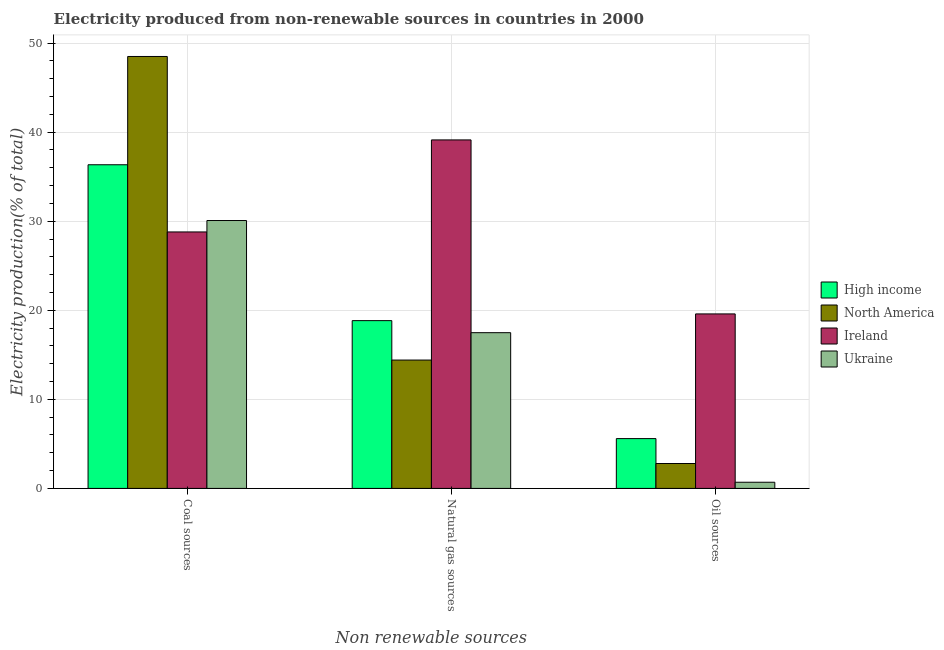How many bars are there on the 2nd tick from the left?
Give a very brief answer. 4. What is the label of the 1st group of bars from the left?
Make the answer very short. Coal sources. What is the percentage of electricity produced by coal in Ireland?
Your answer should be very brief. 28.8. Across all countries, what is the maximum percentage of electricity produced by oil sources?
Ensure brevity in your answer.  19.59. Across all countries, what is the minimum percentage of electricity produced by natural gas?
Your answer should be very brief. 14.41. In which country was the percentage of electricity produced by coal minimum?
Keep it short and to the point. Ireland. What is the total percentage of electricity produced by natural gas in the graph?
Give a very brief answer. 89.86. What is the difference between the percentage of electricity produced by natural gas in Ukraine and that in High income?
Ensure brevity in your answer.  -1.35. What is the difference between the percentage of electricity produced by oil sources in High income and the percentage of electricity produced by coal in North America?
Your answer should be compact. -42.9. What is the average percentage of electricity produced by coal per country?
Offer a terse response. 35.93. What is the difference between the percentage of electricity produced by coal and percentage of electricity produced by oil sources in Ireland?
Your answer should be very brief. 9.2. In how many countries, is the percentage of electricity produced by natural gas greater than 12 %?
Your response must be concise. 4. What is the ratio of the percentage of electricity produced by oil sources in North America to that in High income?
Make the answer very short. 0.5. Is the difference between the percentage of electricity produced by natural gas in Ukraine and North America greater than the difference between the percentage of electricity produced by oil sources in Ukraine and North America?
Keep it short and to the point. Yes. What is the difference between the highest and the second highest percentage of electricity produced by coal?
Make the answer very short. 12.16. What is the difference between the highest and the lowest percentage of electricity produced by natural gas?
Provide a succinct answer. 24.72. In how many countries, is the percentage of electricity produced by oil sources greater than the average percentage of electricity produced by oil sources taken over all countries?
Your answer should be compact. 1. What does the 2nd bar from the right in Oil sources represents?
Make the answer very short. Ireland. Does the graph contain any zero values?
Your answer should be very brief. No. Does the graph contain grids?
Offer a terse response. Yes. How many legend labels are there?
Your answer should be compact. 4. What is the title of the graph?
Provide a succinct answer. Electricity produced from non-renewable sources in countries in 2000. Does "Ecuador" appear as one of the legend labels in the graph?
Provide a succinct answer. No. What is the label or title of the X-axis?
Your response must be concise. Non renewable sources. What is the label or title of the Y-axis?
Give a very brief answer. Electricity production(% of total). What is the Electricity production(% of total) of High income in Coal sources?
Your answer should be very brief. 36.34. What is the Electricity production(% of total) of North America in Coal sources?
Your response must be concise. 48.5. What is the Electricity production(% of total) in Ireland in Coal sources?
Your response must be concise. 28.8. What is the Electricity production(% of total) of Ukraine in Coal sources?
Provide a short and direct response. 30.08. What is the Electricity production(% of total) of High income in Natural gas sources?
Ensure brevity in your answer.  18.84. What is the Electricity production(% of total) in North America in Natural gas sources?
Ensure brevity in your answer.  14.41. What is the Electricity production(% of total) of Ireland in Natural gas sources?
Your answer should be very brief. 39.13. What is the Electricity production(% of total) in Ukraine in Natural gas sources?
Offer a terse response. 17.49. What is the Electricity production(% of total) of High income in Oil sources?
Offer a very short reply. 5.59. What is the Electricity production(% of total) of North America in Oil sources?
Provide a succinct answer. 2.8. What is the Electricity production(% of total) of Ireland in Oil sources?
Ensure brevity in your answer.  19.59. What is the Electricity production(% of total) of Ukraine in Oil sources?
Offer a terse response. 0.69. Across all Non renewable sources, what is the maximum Electricity production(% of total) of High income?
Provide a short and direct response. 36.34. Across all Non renewable sources, what is the maximum Electricity production(% of total) of North America?
Your response must be concise. 48.5. Across all Non renewable sources, what is the maximum Electricity production(% of total) in Ireland?
Offer a terse response. 39.13. Across all Non renewable sources, what is the maximum Electricity production(% of total) in Ukraine?
Your answer should be compact. 30.08. Across all Non renewable sources, what is the minimum Electricity production(% of total) of High income?
Offer a very short reply. 5.59. Across all Non renewable sources, what is the minimum Electricity production(% of total) of North America?
Offer a terse response. 2.8. Across all Non renewable sources, what is the minimum Electricity production(% of total) in Ireland?
Your answer should be very brief. 19.59. Across all Non renewable sources, what is the minimum Electricity production(% of total) of Ukraine?
Your answer should be very brief. 0.69. What is the total Electricity production(% of total) of High income in the graph?
Offer a very short reply. 60.77. What is the total Electricity production(% of total) of North America in the graph?
Keep it short and to the point. 65.71. What is the total Electricity production(% of total) of Ireland in the graph?
Make the answer very short. 87.52. What is the total Electricity production(% of total) of Ukraine in the graph?
Make the answer very short. 48.26. What is the difference between the Electricity production(% of total) of High income in Coal sources and that in Natural gas sources?
Your response must be concise. 17.5. What is the difference between the Electricity production(% of total) in North America in Coal sources and that in Natural gas sources?
Your response must be concise. 34.09. What is the difference between the Electricity production(% of total) of Ireland in Coal sources and that in Natural gas sources?
Your answer should be compact. -10.33. What is the difference between the Electricity production(% of total) of Ukraine in Coal sources and that in Natural gas sources?
Your answer should be compact. 12.59. What is the difference between the Electricity production(% of total) in High income in Coal sources and that in Oil sources?
Your answer should be very brief. 30.75. What is the difference between the Electricity production(% of total) in North America in Coal sources and that in Oil sources?
Offer a very short reply. 45.7. What is the difference between the Electricity production(% of total) of Ireland in Coal sources and that in Oil sources?
Your answer should be compact. 9.2. What is the difference between the Electricity production(% of total) in Ukraine in Coal sources and that in Oil sources?
Offer a terse response. 29.38. What is the difference between the Electricity production(% of total) of High income in Natural gas sources and that in Oil sources?
Give a very brief answer. 13.25. What is the difference between the Electricity production(% of total) of North America in Natural gas sources and that in Oil sources?
Provide a short and direct response. 11.62. What is the difference between the Electricity production(% of total) of Ireland in Natural gas sources and that in Oil sources?
Your response must be concise. 19.54. What is the difference between the Electricity production(% of total) in Ukraine in Natural gas sources and that in Oil sources?
Give a very brief answer. 16.79. What is the difference between the Electricity production(% of total) of High income in Coal sources and the Electricity production(% of total) of North America in Natural gas sources?
Provide a short and direct response. 21.93. What is the difference between the Electricity production(% of total) in High income in Coal sources and the Electricity production(% of total) in Ireland in Natural gas sources?
Make the answer very short. -2.79. What is the difference between the Electricity production(% of total) of High income in Coal sources and the Electricity production(% of total) of Ukraine in Natural gas sources?
Keep it short and to the point. 18.85. What is the difference between the Electricity production(% of total) of North America in Coal sources and the Electricity production(% of total) of Ireland in Natural gas sources?
Ensure brevity in your answer.  9.37. What is the difference between the Electricity production(% of total) of North America in Coal sources and the Electricity production(% of total) of Ukraine in Natural gas sources?
Provide a succinct answer. 31.01. What is the difference between the Electricity production(% of total) in Ireland in Coal sources and the Electricity production(% of total) in Ukraine in Natural gas sources?
Your answer should be compact. 11.31. What is the difference between the Electricity production(% of total) of High income in Coal sources and the Electricity production(% of total) of North America in Oil sources?
Your answer should be compact. 33.54. What is the difference between the Electricity production(% of total) in High income in Coal sources and the Electricity production(% of total) in Ireland in Oil sources?
Provide a short and direct response. 16.75. What is the difference between the Electricity production(% of total) in High income in Coal sources and the Electricity production(% of total) in Ukraine in Oil sources?
Your answer should be compact. 35.65. What is the difference between the Electricity production(% of total) of North America in Coal sources and the Electricity production(% of total) of Ireland in Oil sources?
Make the answer very short. 28.91. What is the difference between the Electricity production(% of total) in North America in Coal sources and the Electricity production(% of total) in Ukraine in Oil sources?
Ensure brevity in your answer.  47.8. What is the difference between the Electricity production(% of total) of Ireland in Coal sources and the Electricity production(% of total) of Ukraine in Oil sources?
Make the answer very short. 28.1. What is the difference between the Electricity production(% of total) in High income in Natural gas sources and the Electricity production(% of total) in North America in Oil sources?
Your response must be concise. 16.04. What is the difference between the Electricity production(% of total) of High income in Natural gas sources and the Electricity production(% of total) of Ireland in Oil sources?
Offer a terse response. -0.75. What is the difference between the Electricity production(% of total) of High income in Natural gas sources and the Electricity production(% of total) of Ukraine in Oil sources?
Give a very brief answer. 18.15. What is the difference between the Electricity production(% of total) in North America in Natural gas sources and the Electricity production(% of total) in Ireland in Oil sources?
Provide a short and direct response. -5.18. What is the difference between the Electricity production(% of total) in North America in Natural gas sources and the Electricity production(% of total) in Ukraine in Oil sources?
Your response must be concise. 13.72. What is the difference between the Electricity production(% of total) of Ireland in Natural gas sources and the Electricity production(% of total) of Ukraine in Oil sources?
Offer a very short reply. 38.44. What is the average Electricity production(% of total) in High income per Non renewable sources?
Offer a terse response. 20.26. What is the average Electricity production(% of total) of North America per Non renewable sources?
Ensure brevity in your answer.  21.9. What is the average Electricity production(% of total) of Ireland per Non renewable sources?
Provide a succinct answer. 29.17. What is the average Electricity production(% of total) of Ukraine per Non renewable sources?
Make the answer very short. 16.09. What is the difference between the Electricity production(% of total) in High income and Electricity production(% of total) in North America in Coal sources?
Provide a short and direct response. -12.16. What is the difference between the Electricity production(% of total) in High income and Electricity production(% of total) in Ireland in Coal sources?
Provide a succinct answer. 7.54. What is the difference between the Electricity production(% of total) of High income and Electricity production(% of total) of Ukraine in Coal sources?
Make the answer very short. 6.26. What is the difference between the Electricity production(% of total) of North America and Electricity production(% of total) of Ireland in Coal sources?
Provide a succinct answer. 19.7. What is the difference between the Electricity production(% of total) in North America and Electricity production(% of total) in Ukraine in Coal sources?
Provide a succinct answer. 18.42. What is the difference between the Electricity production(% of total) in Ireland and Electricity production(% of total) in Ukraine in Coal sources?
Ensure brevity in your answer.  -1.28. What is the difference between the Electricity production(% of total) of High income and Electricity production(% of total) of North America in Natural gas sources?
Keep it short and to the point. 4.43. What is the difference between the Electricity production(% of total) of High income and Electricity production(% of total) of Ireland in Natural gas sources?
Ensure brevity in your answer.  -20.29. What is the difference between the Electricity production(% of total) in High income and Electricity production(% of total) in Ukraine in Natural gas sources?
Provide a succinct answer. 1.35. What is the difference between the Electricity production(% of total) of North America and Electricity production(% of total) of Ireland in Natural gas sources?
Provide a short and direct response. -24.72. What is the difference between the Electricity production(% of total) in North America and Electricity production(% of total) in Ukraine in Natural gas sources?
Your response must be concise. -3.07. What is the difference between the Electricity production(% of total) of Ireland and Electricity production(% of total) of Ukraine in Natural gas sources?
Provide a short and direct response. 21.64. What is the difference between the Electricity production(% of total) in High income and Electricity production(% of total) in North America in Oil sources?
Provide a short and direct response. 2.8. What is the difference between the Electricity production(% of total) of High income and Electricity production(% of total) of Ireland in Oil sources?
Your answer should be compact. -14. What is the difference between the Electricity production(% of total) in High income and Electricity production(% of total) in Ukraine in Oil sources?
Your response must be concise. 4.9. What is the difference between the Electricity production(% of total) of North America and Electricity production(% of total) of Ireland in Oil sources?
Your response must be concise. -16.8. What is the difference between the Electricity production(% of total) in North America and Electricity production(% of total) in Ukraine in Oil sources?
Keep it short and to the point. 2.1. What is the difference between the Electricity production(% of total) in Ireland and Electricity production(% of total) in Ukraine in Oil sources?
Offer a terse response. 18.9. What is the ratio of the Electricity production(% of total) in High income in Coal sources to that in Natural gas sources?
Your answer should be compact. 1.93. What is the ratio of the Electricity production(% of total) in North America in Coal sources to that in Natural gas sources?
Ensure brevity in your answer.  3.37. What is the ratio of the Electricity production(% of total) in Ireland in Coal sources to that in Natural gas sources?
Give a very brief answer. 0.74. What is the ratio of the Electricity production(% of total) in Ukraine in Coal sources to that in Natural gas sources?
Provide a succinct answer. 1.72. What is the ratio of the Electricity production(% of total) in High income in Coal sources to that in Oil sources?
Provide a succinct answer. 6.5. What is the ratio of the Electricity production(% of total) in North America in Coal sources to that in Oil sources?
Ensure brevity in your answer.  17.34. What is the ratio of the Electricity production(% of total) of Ireland in Coal sources to that in Oil sources?
Provide a short and direct response. 1.47. What is the ratio of the Electricity production(% of total) of Ukraine in Coal sources to that in Oil sources?
Your response must be concise. 43.4. What is the ratio of the Electricity production(% of total) of High income in Natural gas sources to that in Oil sources?
Offer a terse response. 3.37. What is the ratio of the Electricity production(% of total) of North America in Natural gas sources to that in Oil sources?
Offer a very short reply. 5.15. What is the ratio of the Electricity production(% of total) of Ireland in Natural gas sources to that in Oil sources?
Ensure brevity in your answer.  2. What is the ratio of the Electricity production(% of total) in Ukraine in Natural gas sources to that in Oil sources?
Your answer should be compact. 25.23. What is the difference between the highest and the second highest Electricity production(% of total) in High income?
Provide a succinct answer. 17.5. What is the difference between the highest and the second highest Electricity production(% of total) in North America?
Give a very brief answer. 34.09. What is the difference between the highest and the second highest Electricity production(% of total) in Ireland?
Your answer should be compact. 10.33. What is the difference between the highest and the second highest Electricity production(% of total) of Ukraine?
Make the answer very short. 12.59. What is the difference between the highest and the lowest Electricity production(% of total) of High income?
Your answer should be compact. 30.75. What is the difference between the highest and the lowest Electricity production(% of total) of North America?
Make the answer very short. 45.7. What is the difference between the highest and the lowest Electricity production(% of total) of Ireland?
Provide a succinct answer. 19.54. What is the difference between the highest and the lowest Electricity production(% of total) in Ukraine?
Your answer should be compact. 29.38. 